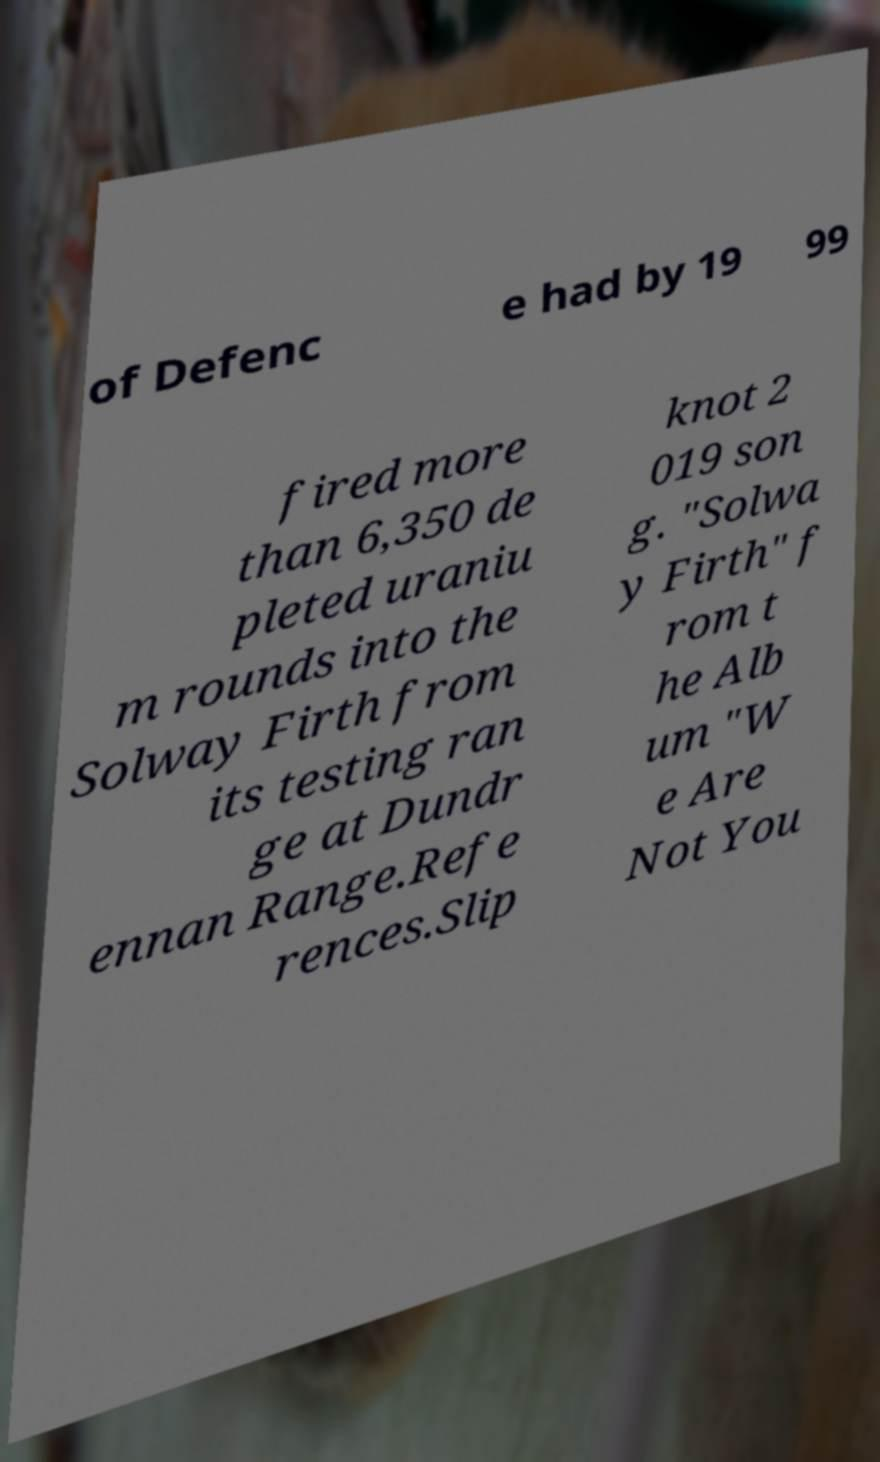There's text embedded in this image that I need extracted. Can you transcribe it verbatim? of Defenc e had by 19 99 fired more than 6,350 de pleted uraniu m rounds into the Solway Firth from its testing ran ge at Dundr ennan Range.Refe rences.Slip knot 2 019 son g. "Solwa y Firth" f rom t he Alb um "W e Are Not You 